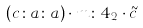<formula> <loc_0><loc_0><loc_500><loc_500>( c \colon a \colon a ) \cdot m \colon 4 _ { 2 } \cdot \tilde { c }</formula> 